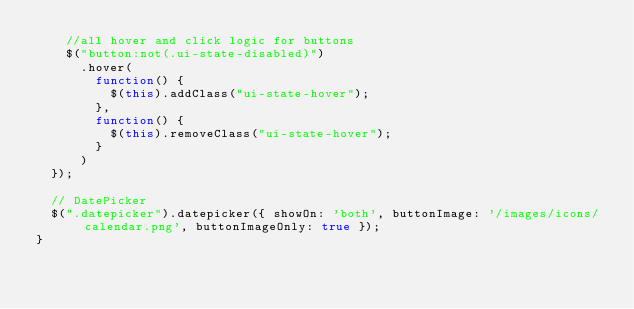Convert code to text. <code><loc_0><loc_0><loc_500><loc_500><_JavaScript_>    //all hover and click logic for buttons
    $("button:not(.ui-state-disabled)")
      .hover(
	      function() {
	        $(this).addClass("ui-state-hover");
	      },
	      function() {
	        $(this).removeClass("ui-state-hover");
	      }
      )
  });

  // DatePicker
  $(".datepicker").datepicker({ showOn: 'both', buttonImage: '/images/icons/calendar.png', buttonImageOnly: true });
}</code> 